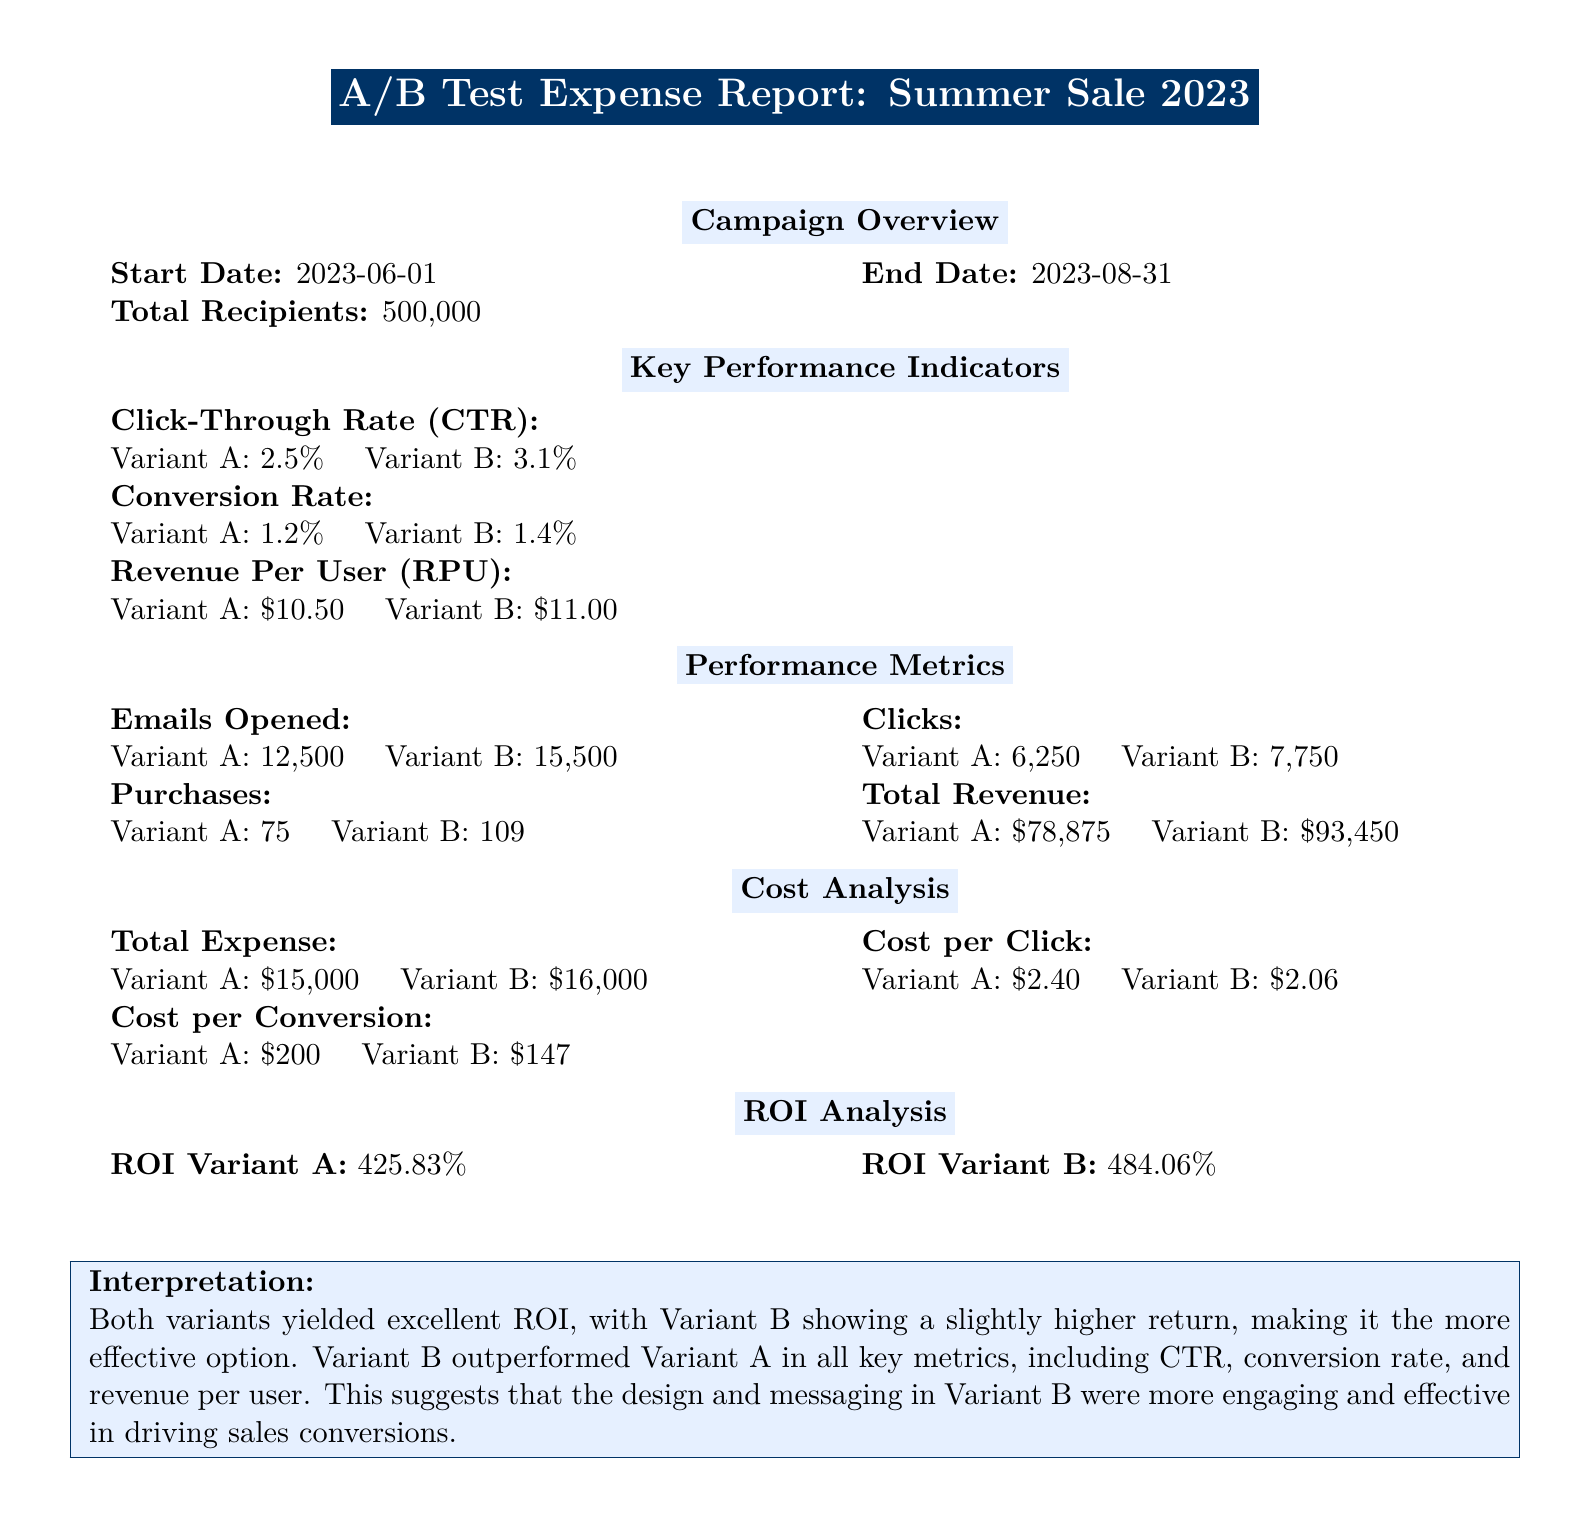what is the start date of the campaign? The start date is clearly indicated in the document as June 1, 2023.
Answer: June 1, 2023 what is the click-through rate for Variant B? The click-through rate for Variant B is explicitly stated in the document.
Answer: 3.1% how much is the total revenue for Variant A? The total revenue for Variant A is listed in the expense report section.
Answer: $78,875 what is the cost per conversion for Variant B? The cost per conversion for Variant B is provided in the cost analysis section of the document.
Answer: $147 which variant had a higher conversion rate? Comparing the conversion rates for both variants indicates which one is higher.
Answer: Variant B what is the ROI for Variant A? The document states the return on investment for Variant A directly.
Answer: 425.83% how many total recipients were there for the campaigns? The total number of recipients is reported in the campaign overview section.
Answer: 500,000 which variant had a lower cost per click? The cost per click for both variants allows us to determine which one is lower.
Answer: Variant B what was the duration of the campaign? The duration can be calculated based on the start and end dates mentioned in the document.
Answer: 3 months 